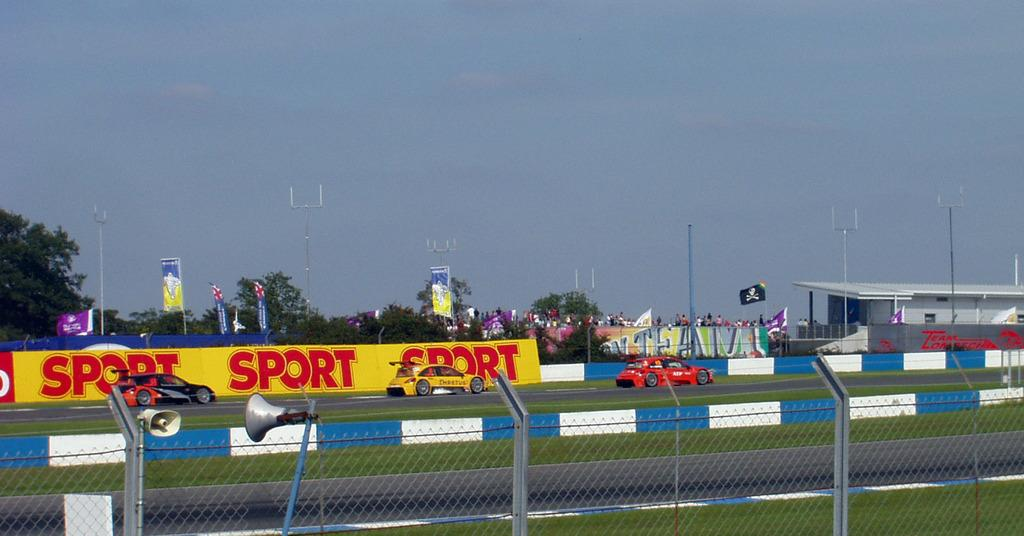<image>
Relay a brief, clear account of the picture shown. Three race cars on a track with a yellow and red sign behind them reading "Sport" 